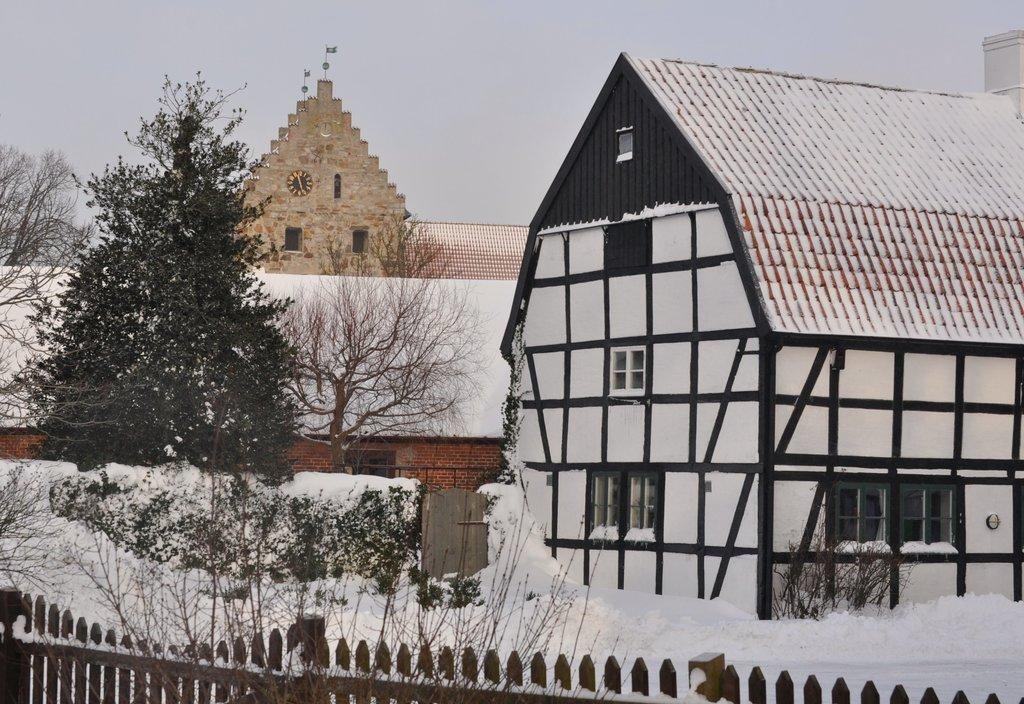Can you describe this image briefly? We can see wooden fence,snow,trees and houses. In the background we can see roof top,wall and sky. 